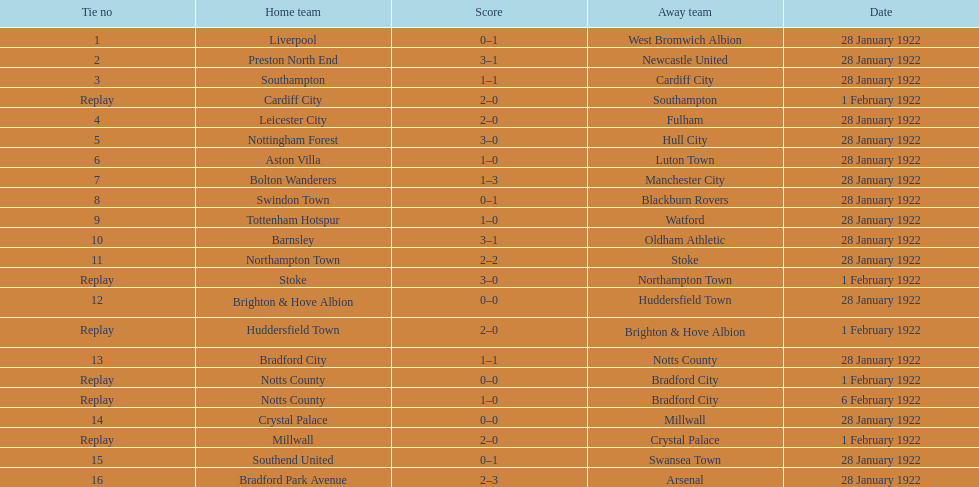In how many games were four or more total points scored? 5. 